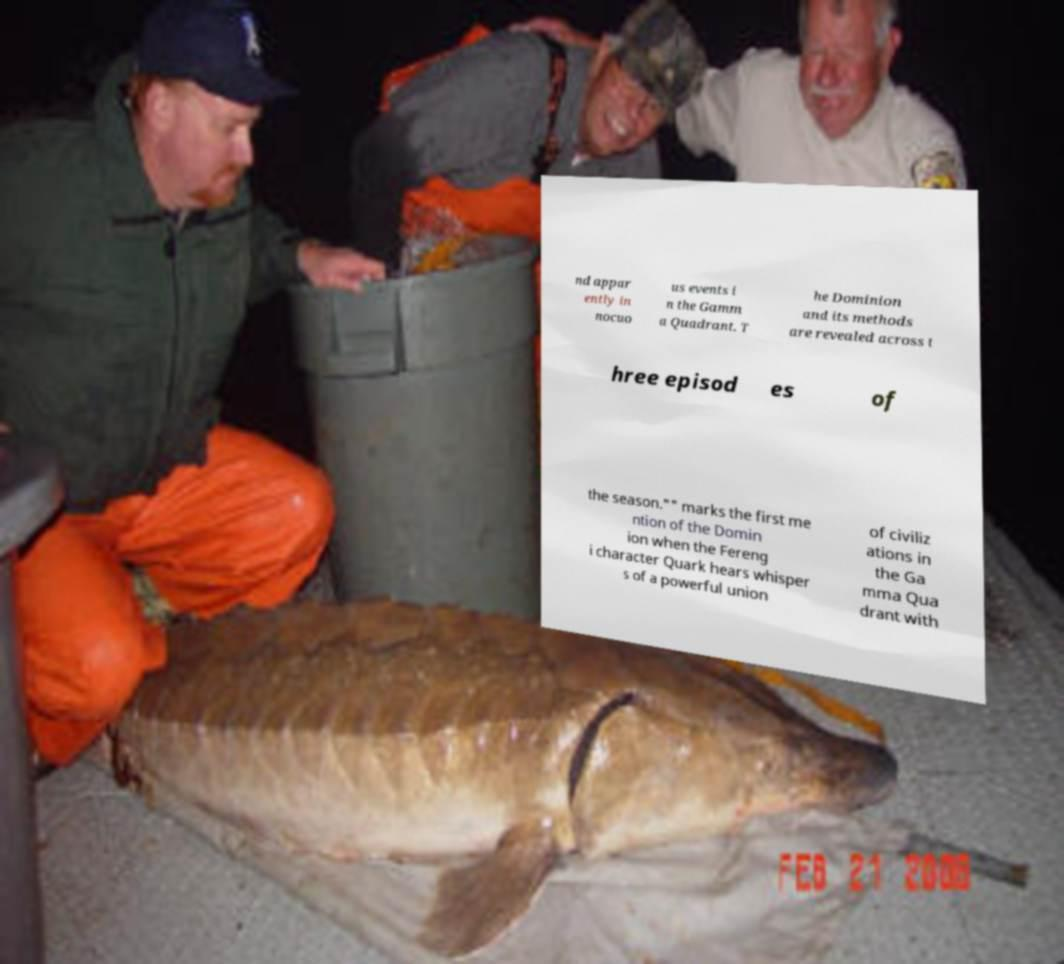There's text embedded in this image that I need extracted. Can you transcribe it verbatim? nd appar ently in nocuo us events i n the Gamm a Quadrant. T he Dominion and its methods are revealed across t hree episod es of the season."" marks the first me ntion of the Domin ion when the Fereng i character Quark hears whisper s of a powerful union of civiliz ations in the Ga mma Qua drant with 